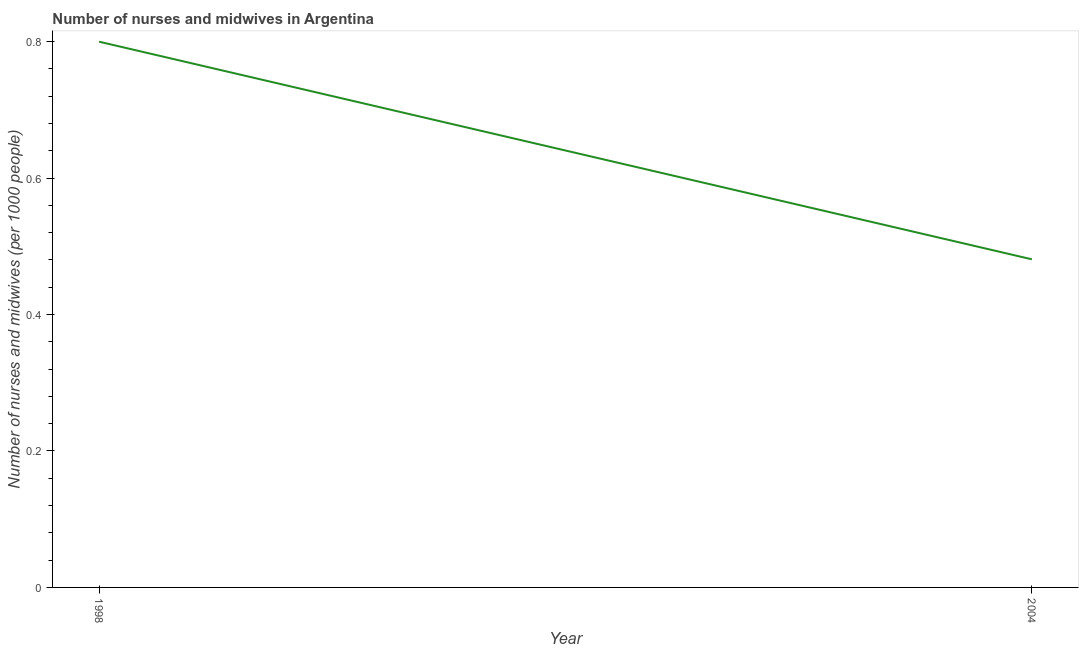Across all years, what is the maximum number of nurses and midwives?
Give a very brief answer. 0.8. Across all years, what is the minimum number of nurses and midwives?
Your answer should be compact. 0.48. In which year was the number of nurses and midwives maximum?
Offer a terse response. 1998. In which year was the number of nurses and midwives minimum?
Your response must be concise. 2004. What is the sum of the number of nurses and midwives?
Your answer should be compact. 1.28. What is the difference between the number of nurses and midwives in 1998 and 2004?
Provide a succinct answer. 0.32. What is the average number of nurses and midwives per year?
Your response must be concise. 0.64. What is the median number of nurses and midwives?
Offer a very short reply. 0.64. Do a majority of the years between 1998 and 2004 (inclusive) have number of nurses and midwives greater than 0.6000000000000001 ?
Ensure brevity in your answer.  No. What is the ratio of the number of nurses and midwives in 1998 to that in 2004?
Your response must be concise. 1.66. Is the number of nurses and midwives in 1998 less than that in 2004?
Provide a short and direct response. No. In how many years, is the number of nurses and midwives greater than the average number of nurses and midwives taken over all years?
Make the answer very short. 1. Does the number of nurses and midwives monotonically increase over the years?
Keep it short and to the point. No. How many lines are there?
Keep it short and to the point. 1. Are the values on the major ticks of Y-axis written in scientific E-notation?
Your answer should be very brief. No. Does the graph contain any zero values?
Provide a short and direct response. No. Does the graph contain grids?
Provide a short and direct response. No. What is the title of the graph?
Give a very brief answer. Number of nurses and midwives in Argentina. What is the label or title of the Y-axis?
Keep it short and to the point. Number of nurses and midwives (per 1000 people). What is the Number of nurses and midwives (per 1000 people) of 2004?
Give a very brief answer. 0.48. What is the difference between the Number of nurses and midwives (per 1000 people) in 1998 and 2004?
Make the answer very short. 0.32. What is the ratio of the Number of nurses and midwives (per 1000 people) in 1998 to that in 2004?
Give a very brief answer. 1.66. 